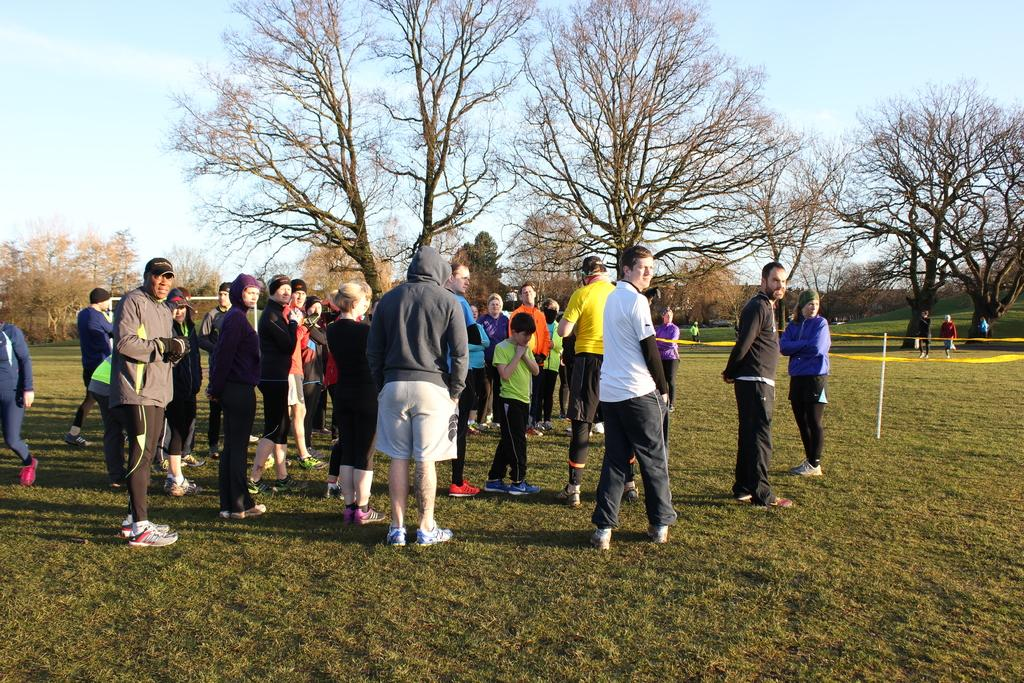How many people are in the image? There are many people in the image. What type of clothing are the people wearing? The people are wearing sweatshirts, hoodies, and pants. Where are the people standing in the image? The people are standing on grassland. What can be seen in the background of the image? There are trees visible in the background. What is the condition of the sky in the image? The sky is visible with clouds. Can you see any kittens playing with your uncle in the image? There are no kittens or uncles present in the image. Is there a volcano erupting in the background of the image? There is no volcano present in the image; only trees and clouds can be seen in the background. 